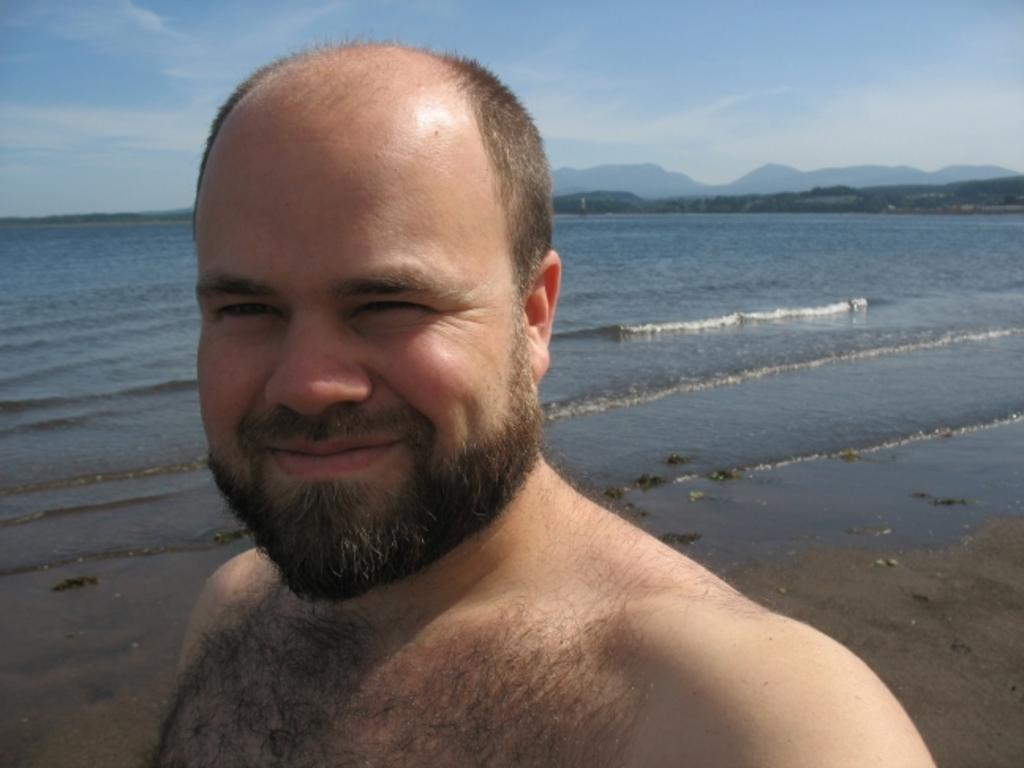Please provide a concise description of this image. This image might be clicked in a beach. There is water in the middle. In the front there is a person, who is smiling. There is sky at the top. 